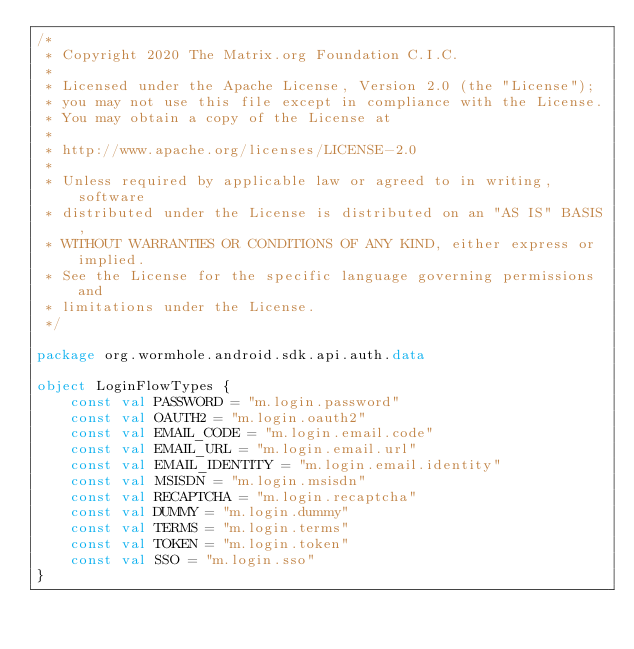Convert code to text. <code><loc_0><loc_0><loc_500><loc_500><_Kotlin_>/*
 * Copyright 2020 The Matrix.org Foundation C.I.C.
 *
 * Licensed under the Apache License, Version 2.0 (the "License");
 * you may not use this file except in compliance with the License.
 * You may obtain a copy of the License at
 *
 * http://www.apache.org/licenses/LICENSE-2.0
 *
 * Unless required by applicable law or agreed to in writing, software
 * distributed under the License is distributed on an "AS IS" BASIS,
 * WITHOUT WARRANTIES OR CONDITIONS OF ANY KIND, either express or implied.
 * See the License for the specific language governing permissions and
 * limitations under the License.
 */

package org.wormhole.android.sdk.api.auth.data

object LoginFlowTypes {
    const val PASSWORD = "m.login.password"
    const val OAUTH2 = "m.login.oauth2"
    const val EMAIL_CODE = "m.login.email.code"
    const val EMAIL_URL = "m.login.email.url"
    const val EMAIL_IDENTITY = "m.login.email.identity"
    const val MSISDN = "m.login.msisdn"
    const val RECAPTCHA = "m.login.recaptcha"
    const val DUMMY = "m.login.dummy"
    const val TERMS = "m.login.terms"
    const val TOKEN = "m.login.token"
    const val SSO = "m.login.sso"
}
</code> 